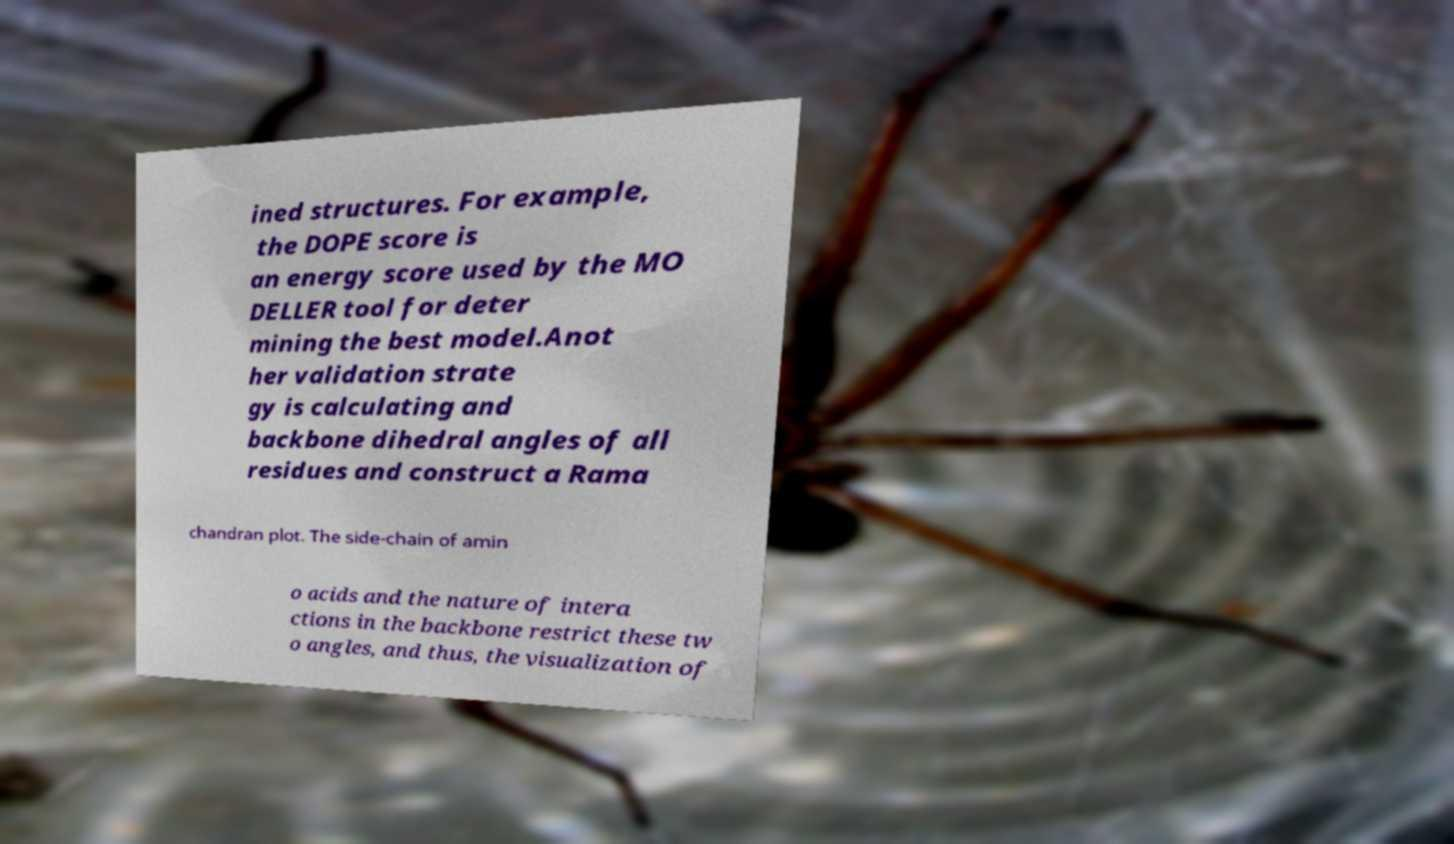Please read and relay the text visible in this image. What does it say? ined structures. For example, the DOPE score is an energy score used by the MO DELLER tool for deter mining the best model.Anot her validation strate gy is calculating and backbone dihedral angles of all residues and construct a Rama chandran plot. The side-chain of amin o acids and the nature of intera ctions in the backbone restrict these tw o angles, and thus, the visualization of 